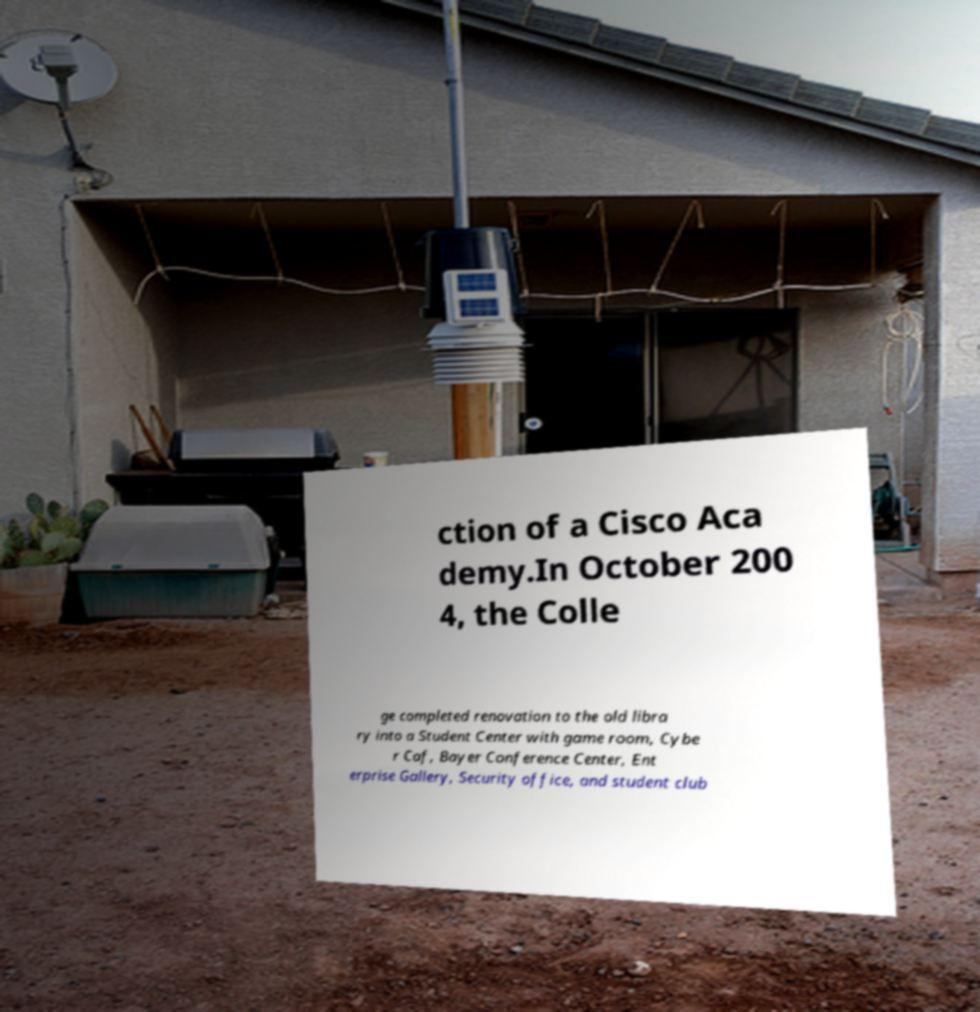Could you extract and type out the text from this image? ction of a Cisco Aca demy.In October 200 4, the Colle ge completed renovation to the old libra ry into a Student Center with game room, Cybe r Caf, Bayer Conference Center, Ent erprise Gallery, Security office, and student club 